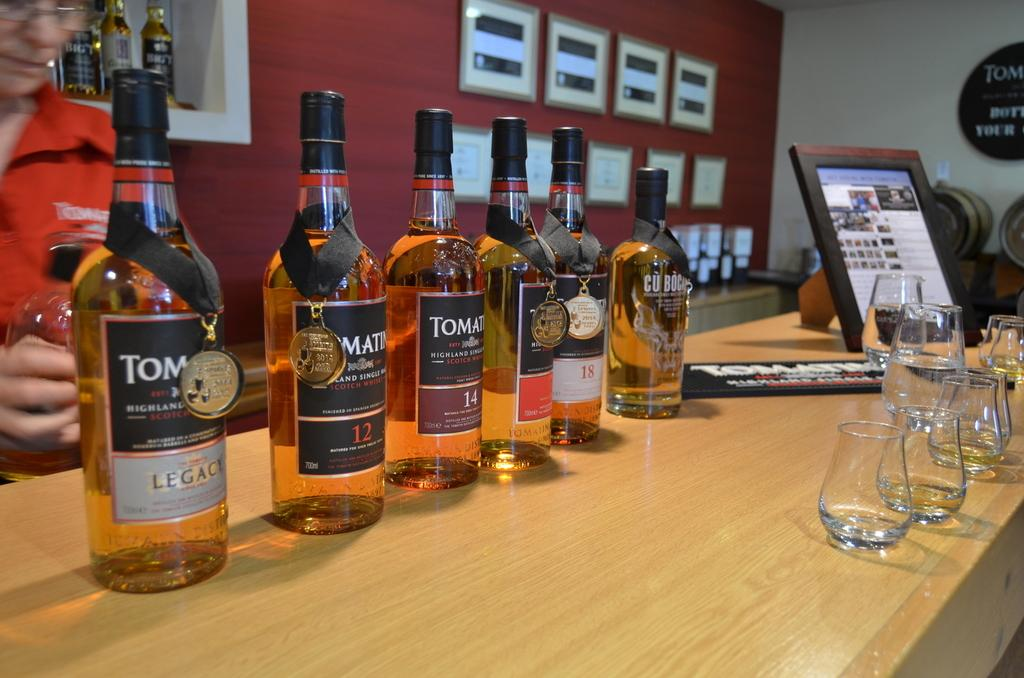<image>
Render a clear and concise summary of the photo. Many bottles on a table including one that has the number 12 on it. 